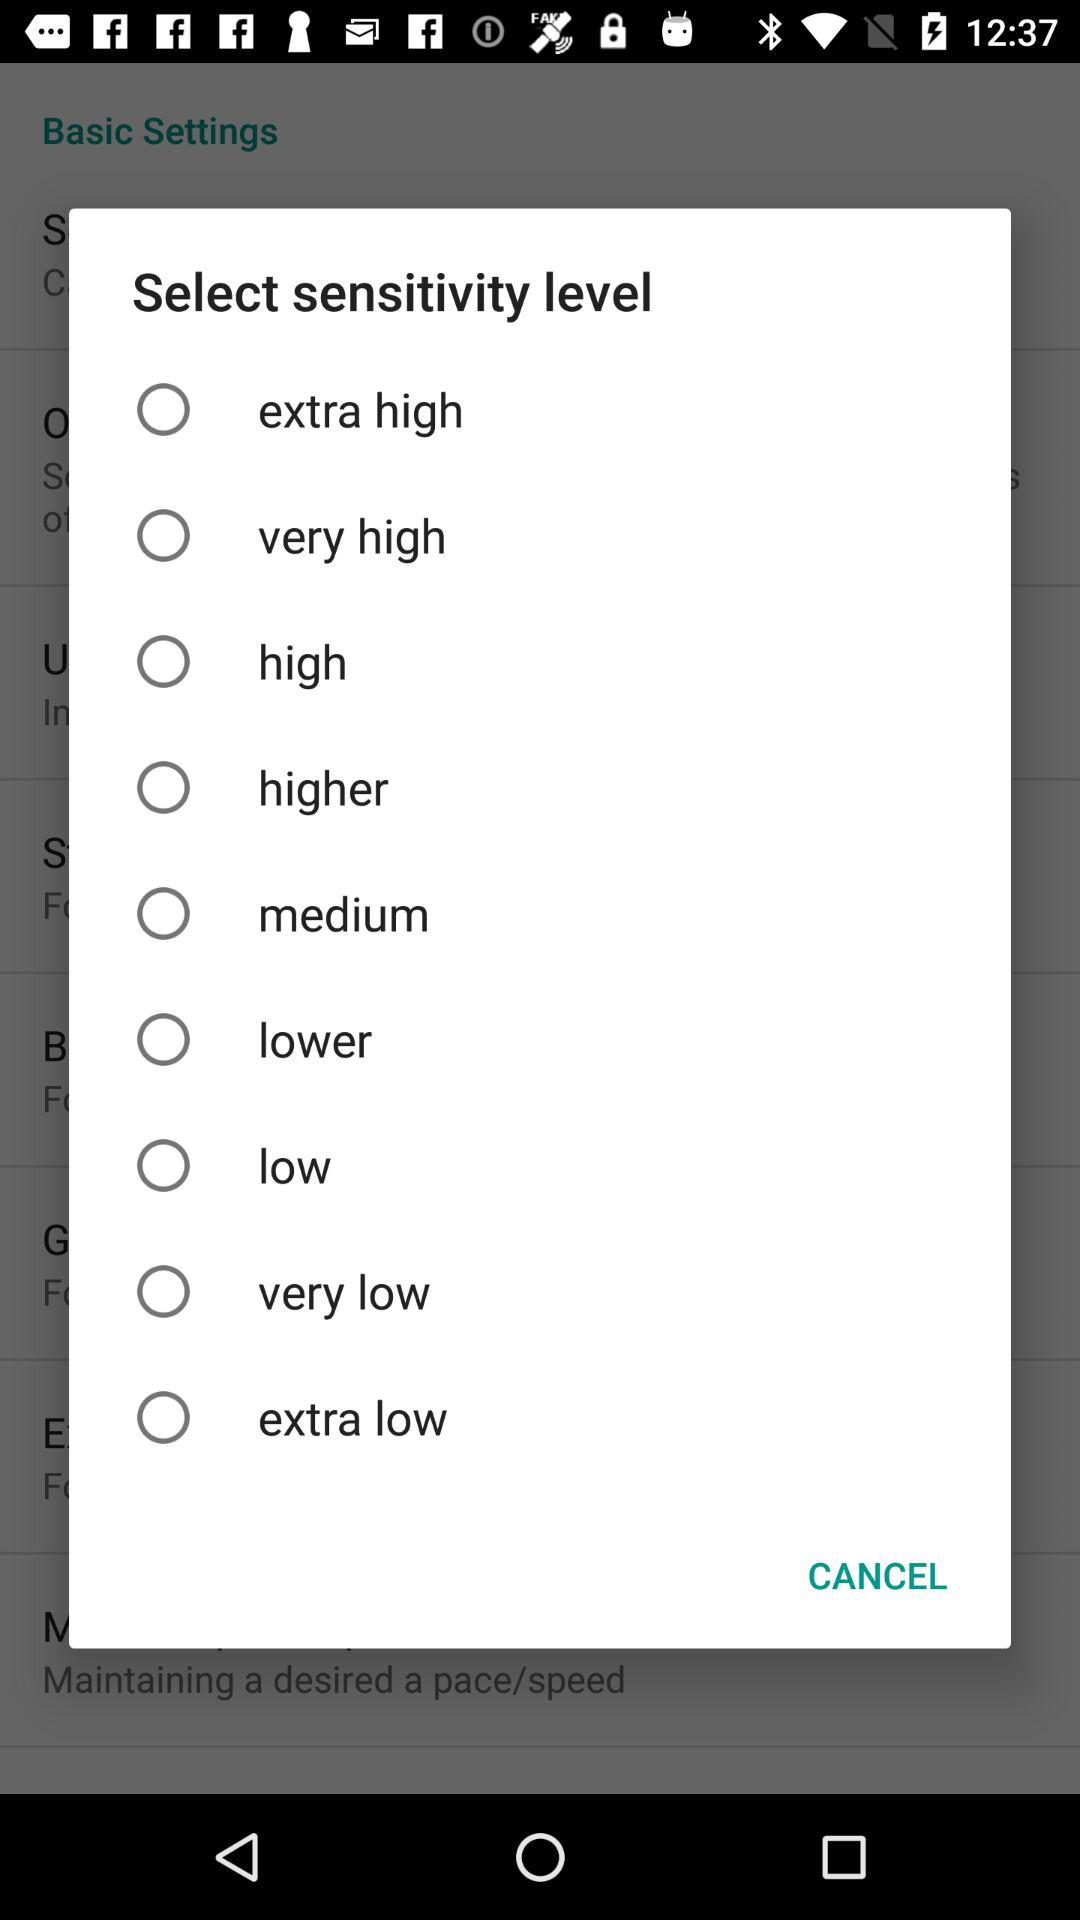How many levels of sensitivity are there?
Answer the question using a single word or phrase. 9 